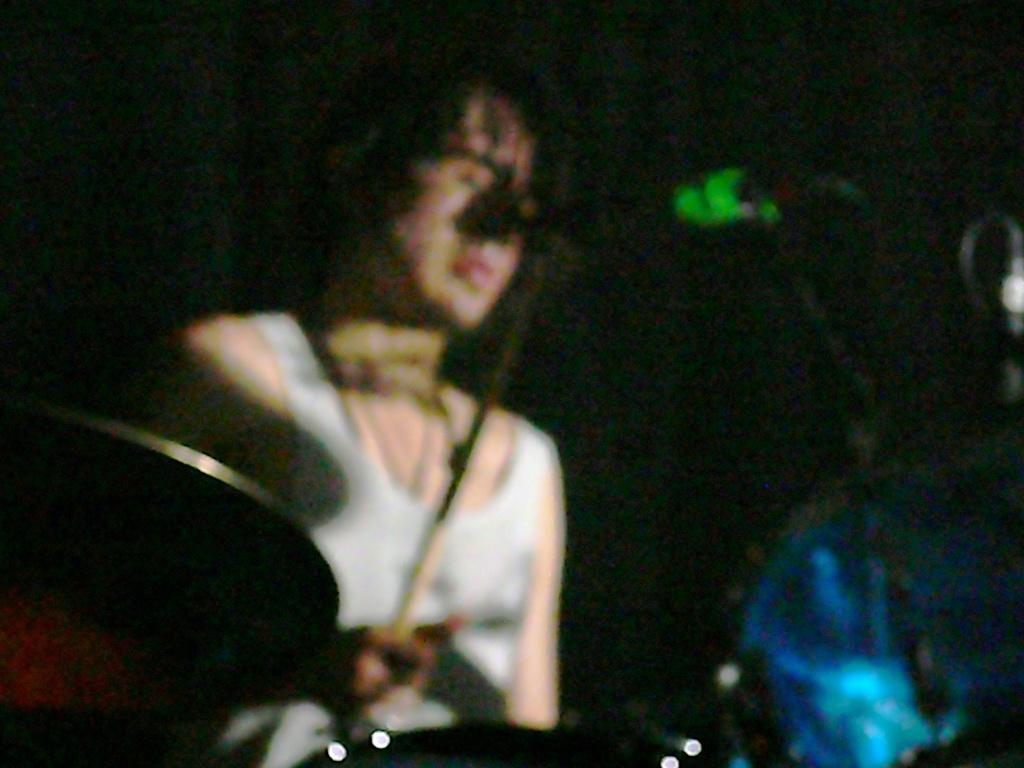Who is the main subject in the image? There is a person in the image. What is the person doing in the image? The person is sitting at a mic. What type of tools does the carpenter have in the image? There is no carpenter or tools present in the image; it features a person sitting at a mic. How many toes can be seen on the person's feet in the image? The image does not show the person's feet, so the number of toes cannot be determined. 